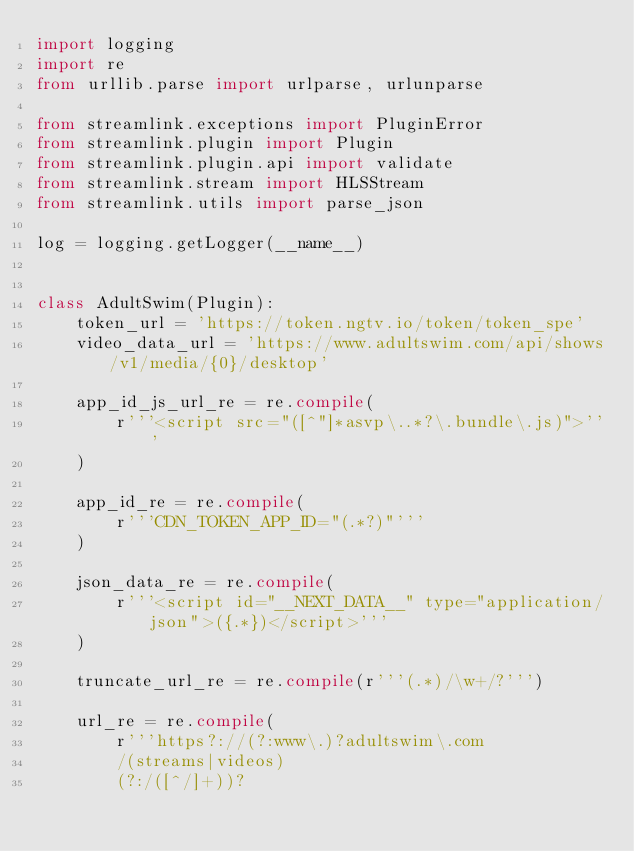<code> <loc_0><loc_0><loc_500><loc_500><_Python_>import logging
import re
from urllib.parse import urlparse, urlunparse

from streamlink.exceptions import PluginError
from streamlink.plugin import Plugin
from streamlink.plugin.api import validate
from streamlink.stream import HLSStream
from streamlink.utils import parse_json

log = logging.getLogger(__name__)


class AdultSwim(Plugin):
    token_url = 'https://token.ngtv.io/token/token_spe'
    video_data_url = 'https://www.adultswim.com/api/shows/v1/media/{0}/desktop'

    app_id_js_url_re = re.compile(
        r'''<script src="([^"]*asvp\..*?\.bundle\.js)">'''
    )

    app_id_re = re.compile(
        r'''CDN_TOKEN_APP_ID="(.*?)"'''
    )

    json_data_re = re.compile(
        r'''<script id="__NEXT_DATA__" type="application/json">({.*})</script>'''
    )

    truncate_url_re = re.compile(r'''(.*)/\w+/?''')

    url_re = re.compile(
        r'''https?://(?:www\.)?adultswim\.com
        /(streams|videos)
        (?:/([^/]+))?</code> 